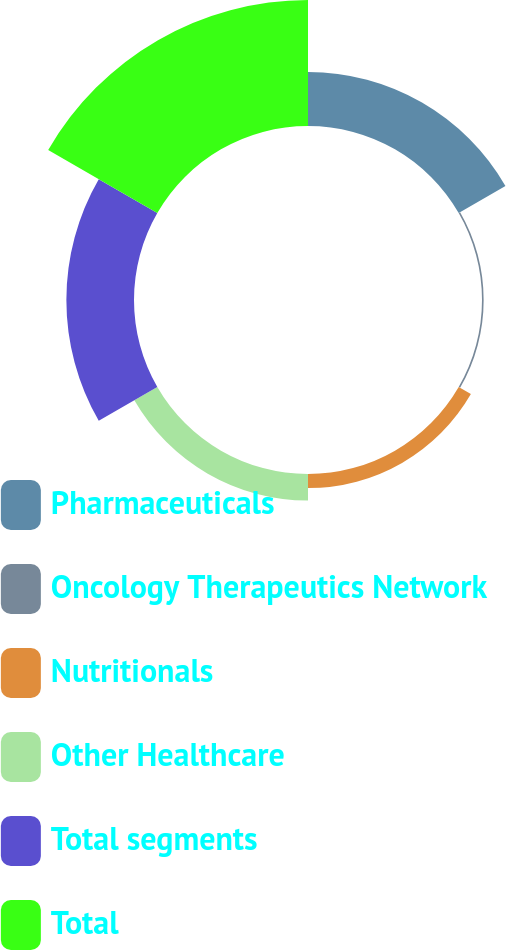Convert chart to OTSL. <chart><loc_0><loc_0><loc_500><loc_500><pie_chart><fcel>Pharmaceuticals<fcel>Oncology Therapeutics Network<fcel>Nutritionals<fcel>Other Healthcare<fcel>Total segments<fcel>Total<nl><fcel>18.63%<fcel>0.57%<fcel>4.86%<fcel>9.15%<fcel>23.33%<fcel>43.47%<nl></chart> 